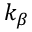Convert formula to latex. <formula><loc_0><loc_0><loc_500><loc_500>k _ { \beta }</formula> 